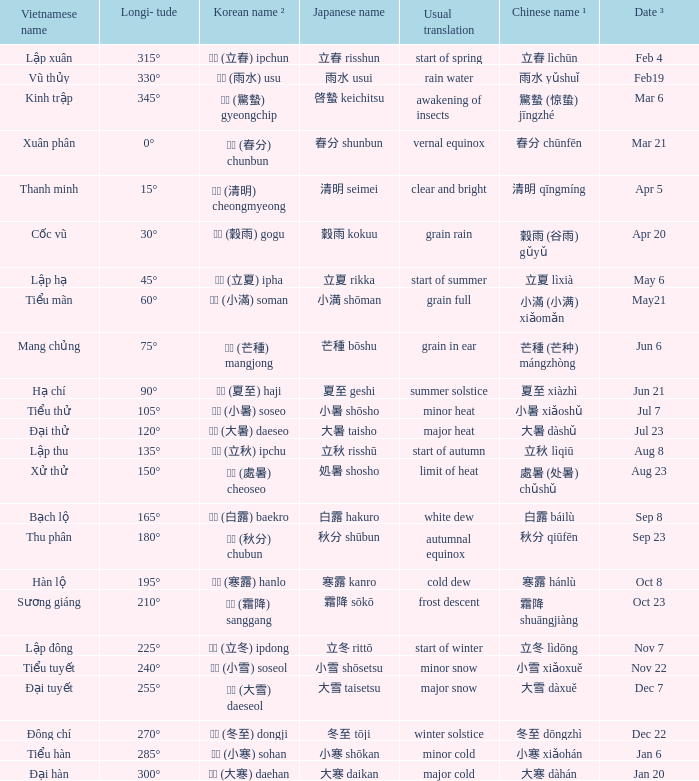When has a Korean name ² of 청명 (清明) cheongmyeong? Apr 5. 